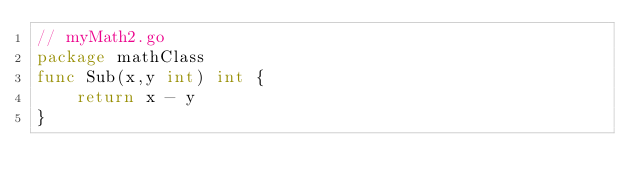<code> <loc_0><loc_0><loc_500><loc_500><_Go_>// myMath2.go
package mathClass
func Sub(x,y int) int {
    return x - y
}</code> 